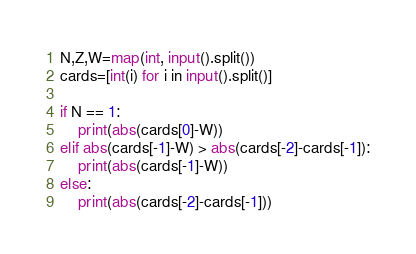<code> <loc_0><loc_0><loc_500><loc_500><_Python_>N,Z,W=map(int, input().split())
cards=[int(i) for i in input().split()]

if N == 1:
    print(abs(cards[0]-W))
elif abs(cards[-1]-W) > abs(cards[-2]-cards[-1]):
    print(abs(cards[-1]-W))
else:
    print(abs(cards[-2]-cards[-1]))</code> 